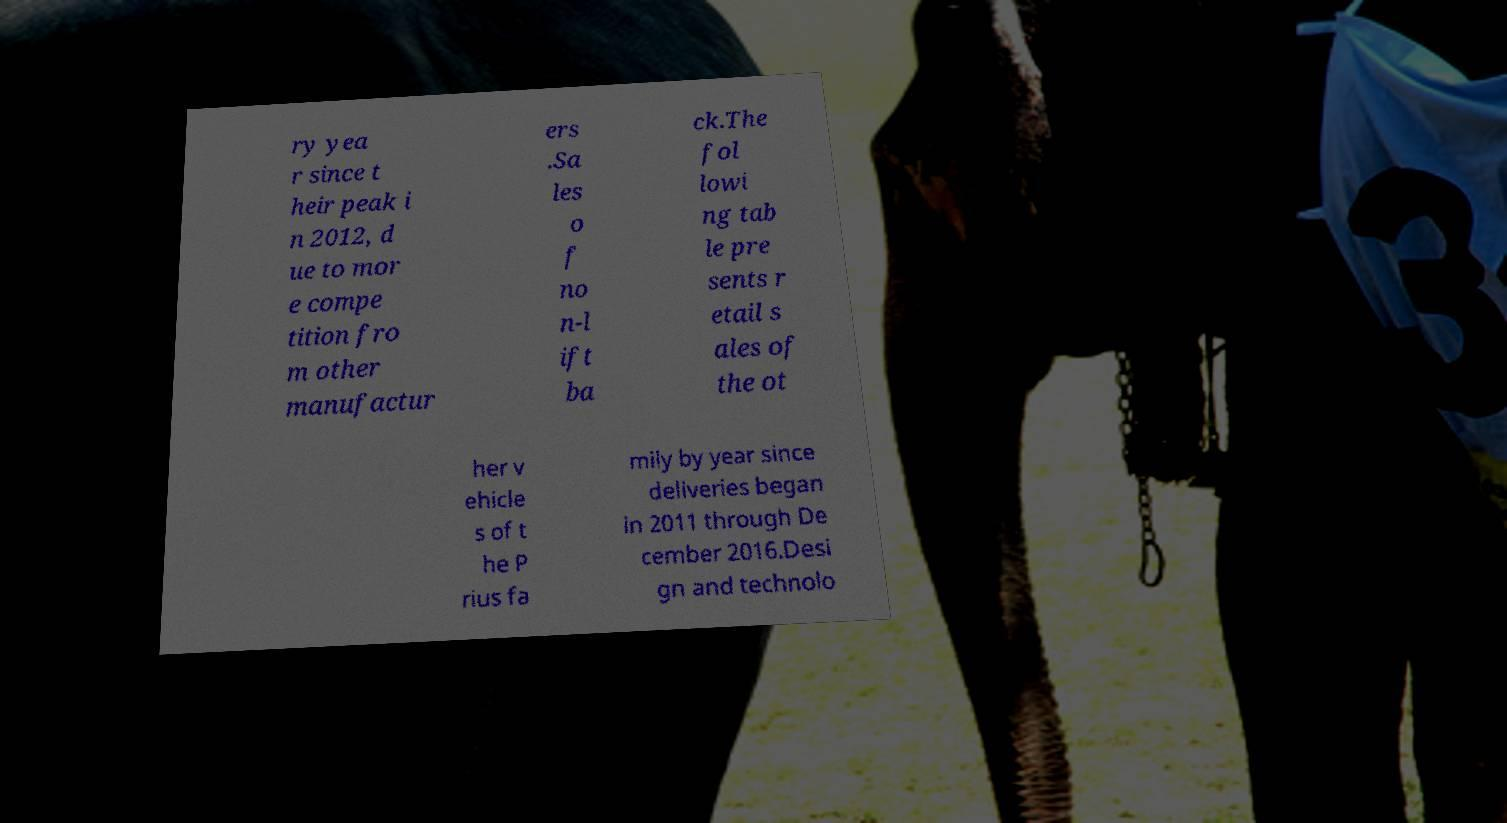For documentation purposes, I need the text within this image transcribed. Could you provide that? ry yea r since t heir peak i n 2012, d ue to mor e compe tition fro m other manufactur ers .Sa les o f no n-l ift ba ck.The fol lowi ng tab le pre sents r etail s ales of the ot her v ehicle s of t he P rius fa mily by year since deliveries began in 2011 through De cember 2016.Desi gn and technolo 